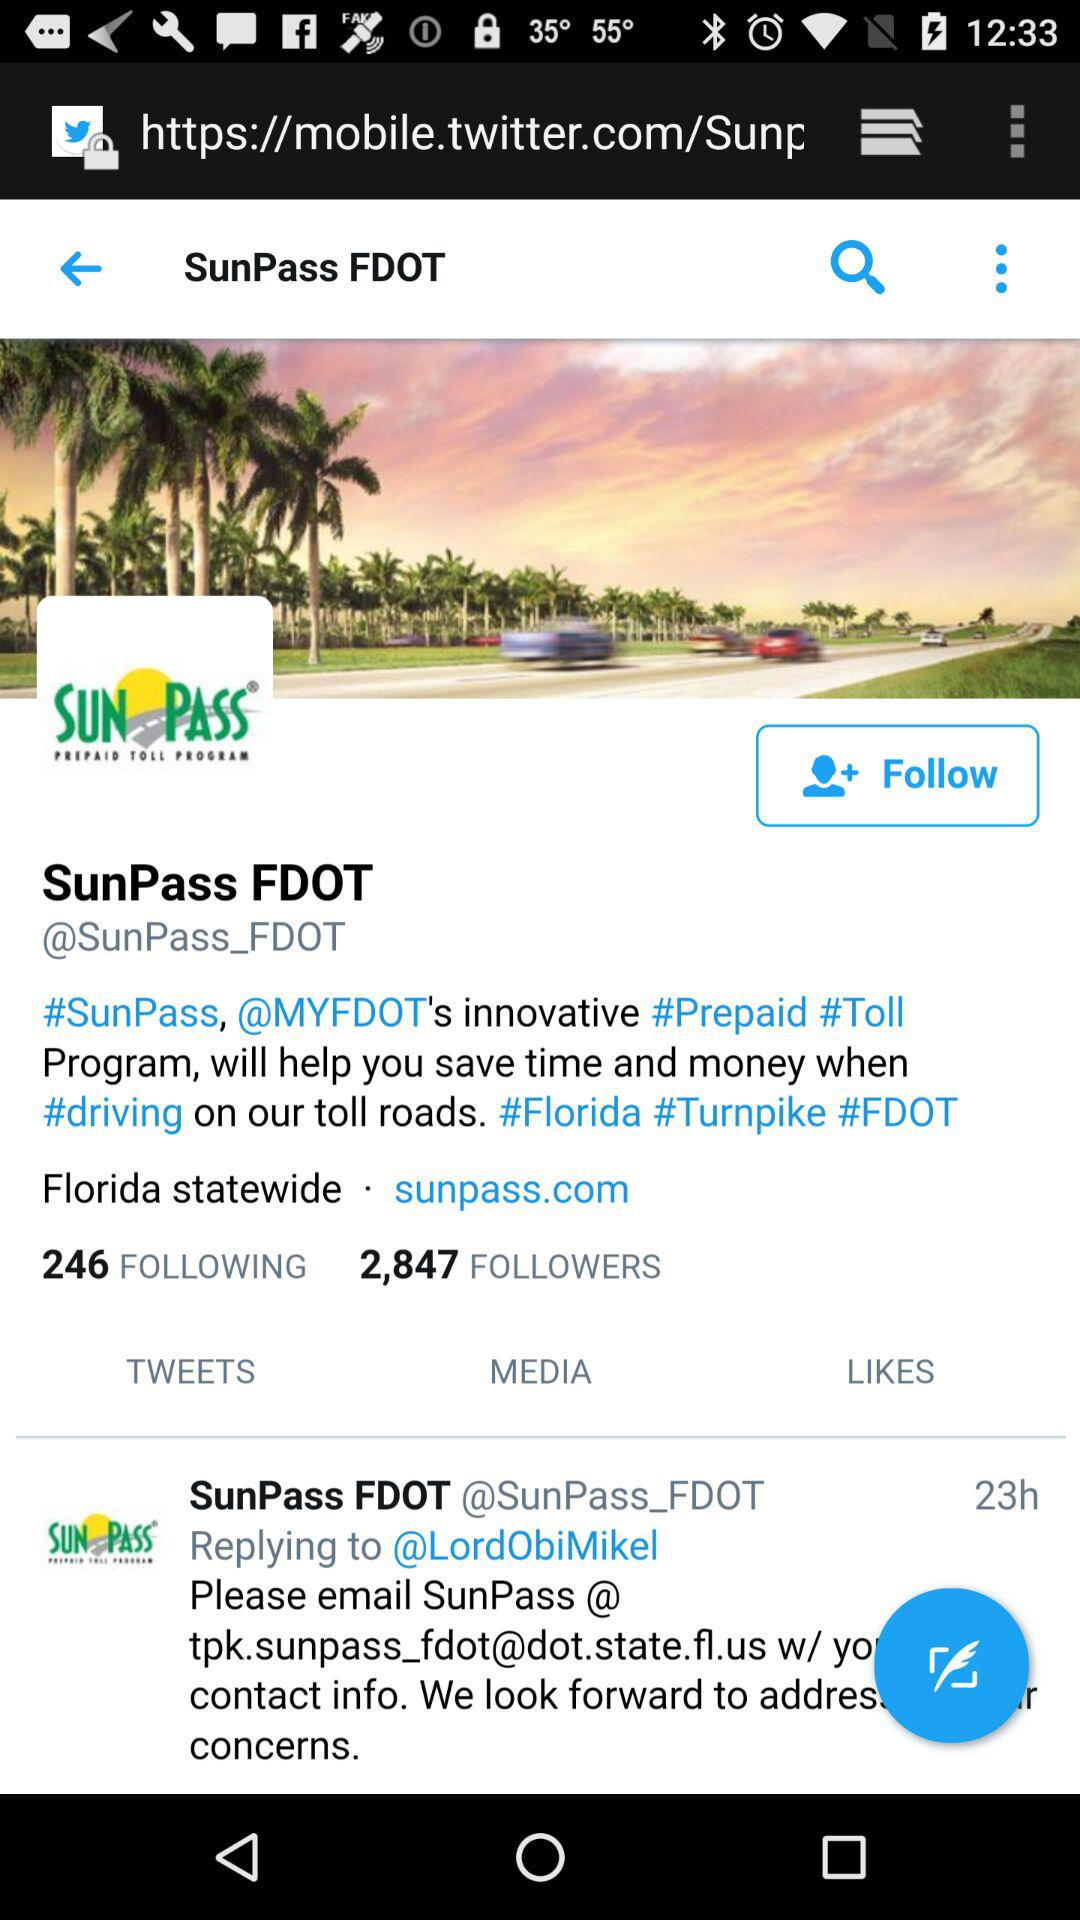How many people are following "SunPass FDOT"? The number of people who are following "SunPass FDOT" is 2,847. 